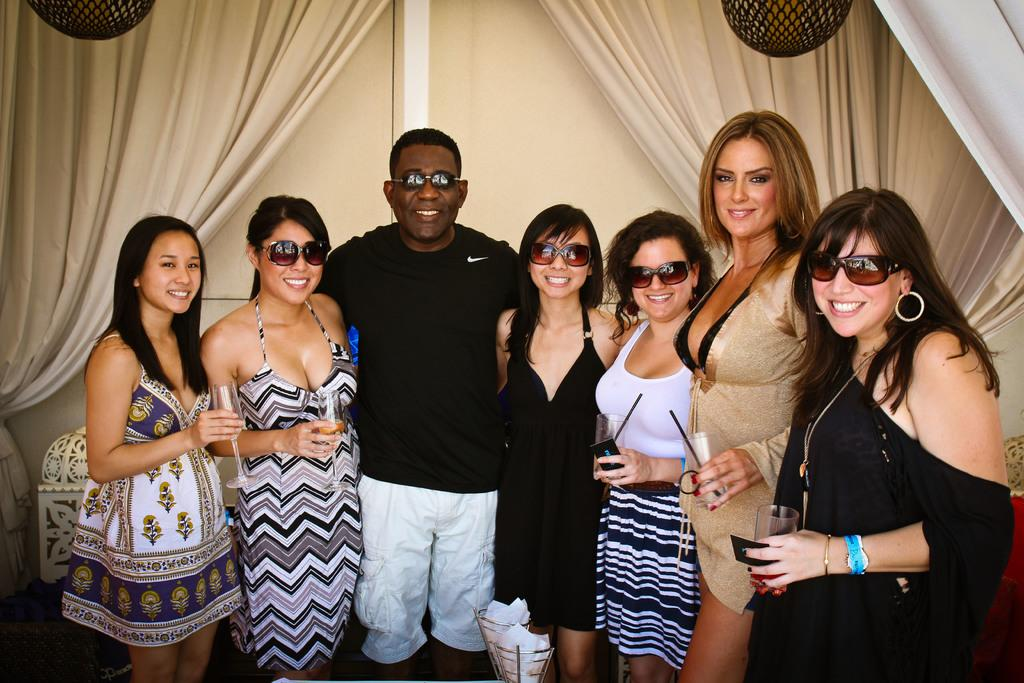How many people are in the image? There is a group of people in the image. What are the people doing in the image? The people are standing and holding glasses. What can be seen in the background of the image? There is a wall and curtains in the background of the image. What type of snails can be seen crawling on the wall in the image? There are no snails present in the image; the background only features a wall and curtains. 